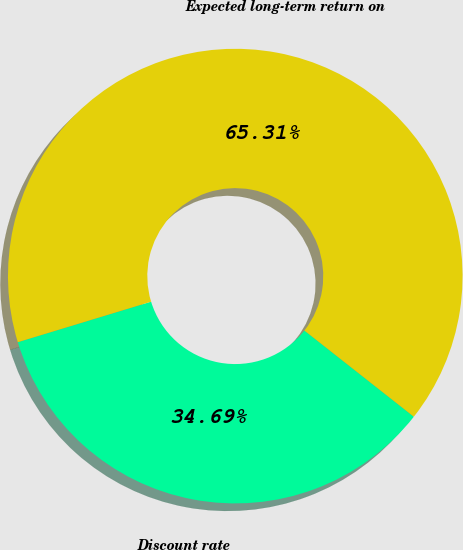Convert chart. <chart><loc_0><loc_0><loc_500><loc_500><pie_chart><fcel>Discount rate<fcel>Expected long-term return on<nl><fcel>34.69%<fcel>65.31%<nl></chart> 